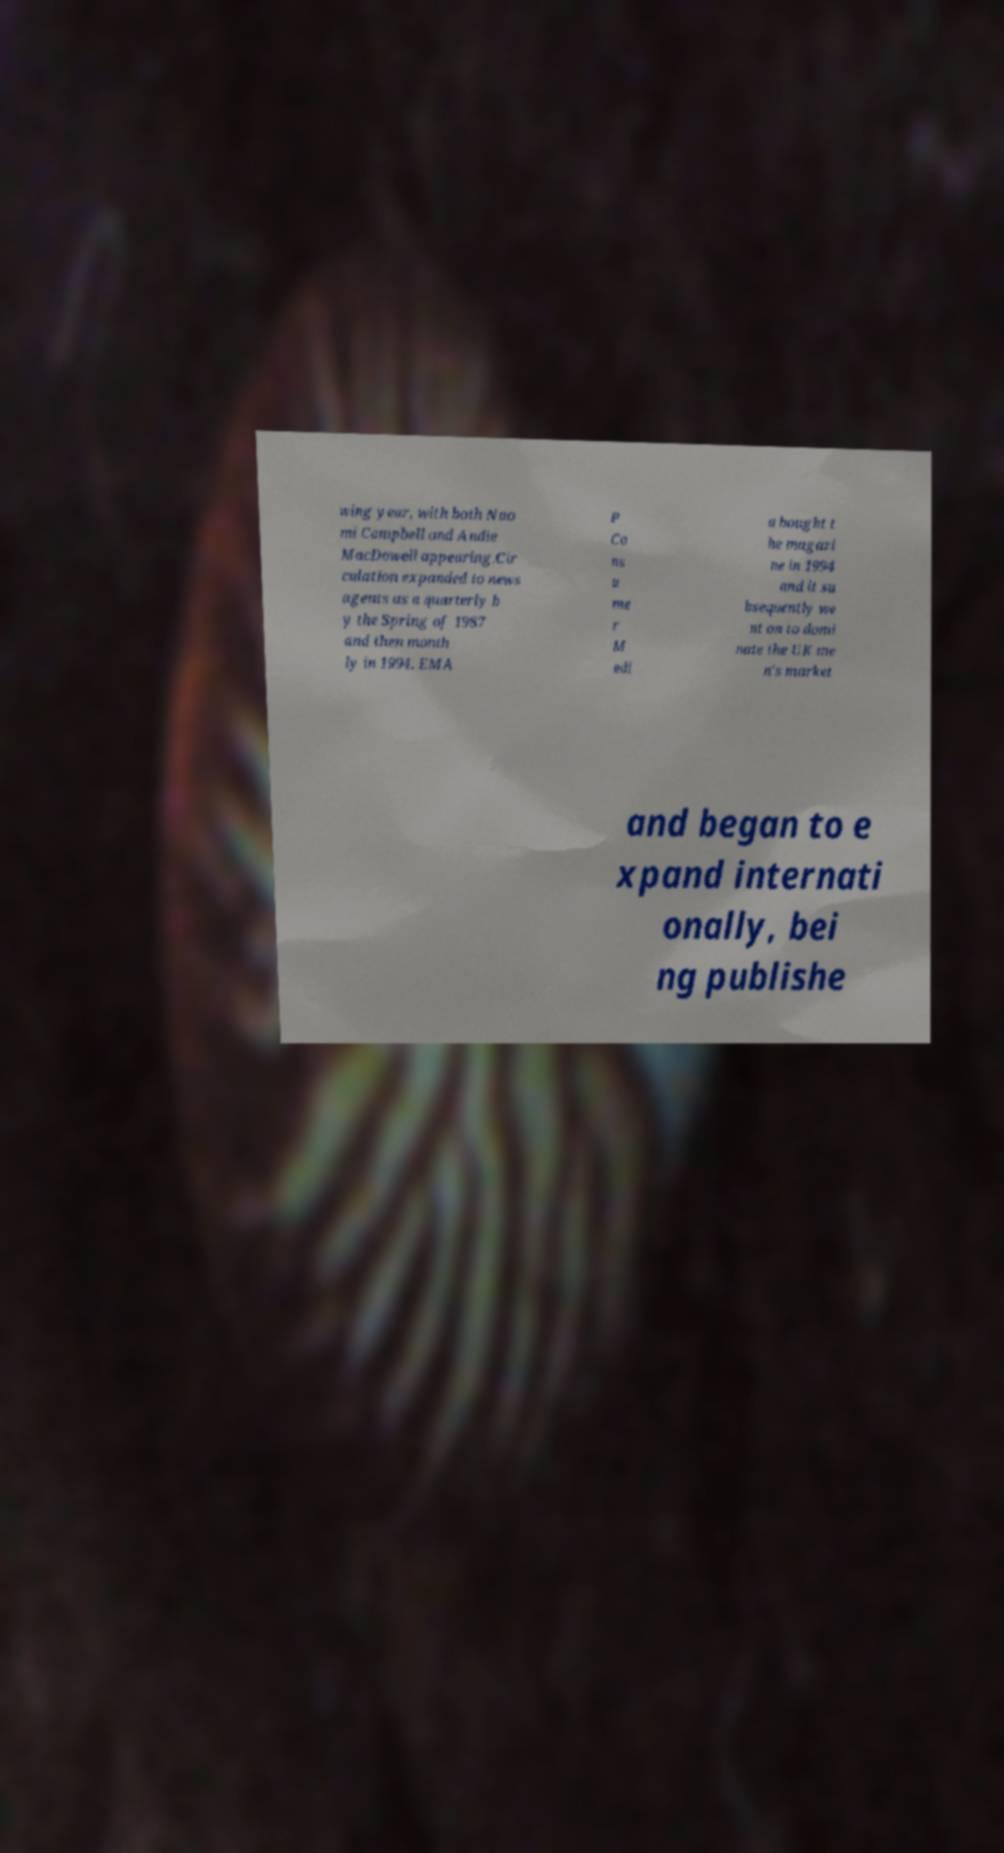Could you extract and type out the text from this image? wing year, with both Nao mi Campbell and Andie MacDowell appearing.Cir culation expanded to news agents as a quarterly b y the Spring of 1987 and then month ly in 1994. EMA P Co ns u me r M edi a bought t he magazi ne in 1994 and it su bsequently we nt on to domi nate the UK me n's market and began to e xpand internati onally, bei ng publishe 